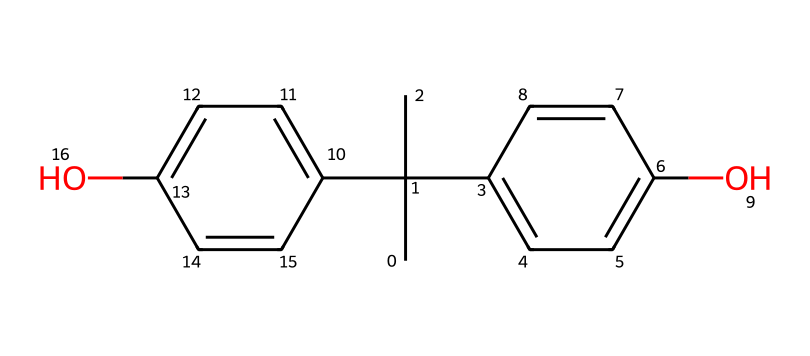What is the number of carbon atoms in bisphenol A? By analyzing the chemical structure represented by the SMILES notation, each letter 'C' corresponds to a carbon atom. Counting them in the structural diagram shows there are 15 carbon atoms in bisphenol A.
Answer: 15 What functional groups are present in bisphenol A? The SMILES representation indicates the presence of hydroxyl groups (–OH), which are characteristic of phenolic compounds. Identifying the structure reveals two hydroxyl functional groups attached to aromatic rings.
Answer: two hydroxyl groups How many rings does bisphenol A contain? The structure of bisphenol A includes two distinct aromatic rings, which are identified within the SMILES notation as 'C1=CC...' and 'C2=CC...'. Each 'C' followed by '=' indicates part of a cyclic structure.
Answer: two rings What type of bonding is present between carbon atoms in bisphenol A? Observing the SMILES structure, carbon atoms are primarily connected by single bonds and some by double bonds (as indicated by '='), which are typical in aromatic compounds. Thus, there is both single and double bonding present.
Answer: single and double bonds Which atom in bisphenol A is responsible for its acidity? The acidic behavior in bisphenol A is due to the presence of the hydroxyl groups (-OH), particularly the oxygen atom in the -OH group that can donate a proton (H+). This is a defining property of phenols, hence it's the oxygen atom.
Answer: oxygen atom Does bisphenol A have an asymmetric carbon? Assessing the structure, there is a carbon atom connected to three different groups (the two aromatic rings and a tert-butyl group), indicating that it is asymmetric and thus provides chirality to the molecule.
Answer: yes What kind of intermolecular forces are likely present in bisphenol A? With the phenolic structure of bisphenol A, the presence of hydroxyl groups allows for hydrogen bonding between molecules. These interactions are crucial for determining its physical properties.
Answer: hydrogen bonding 